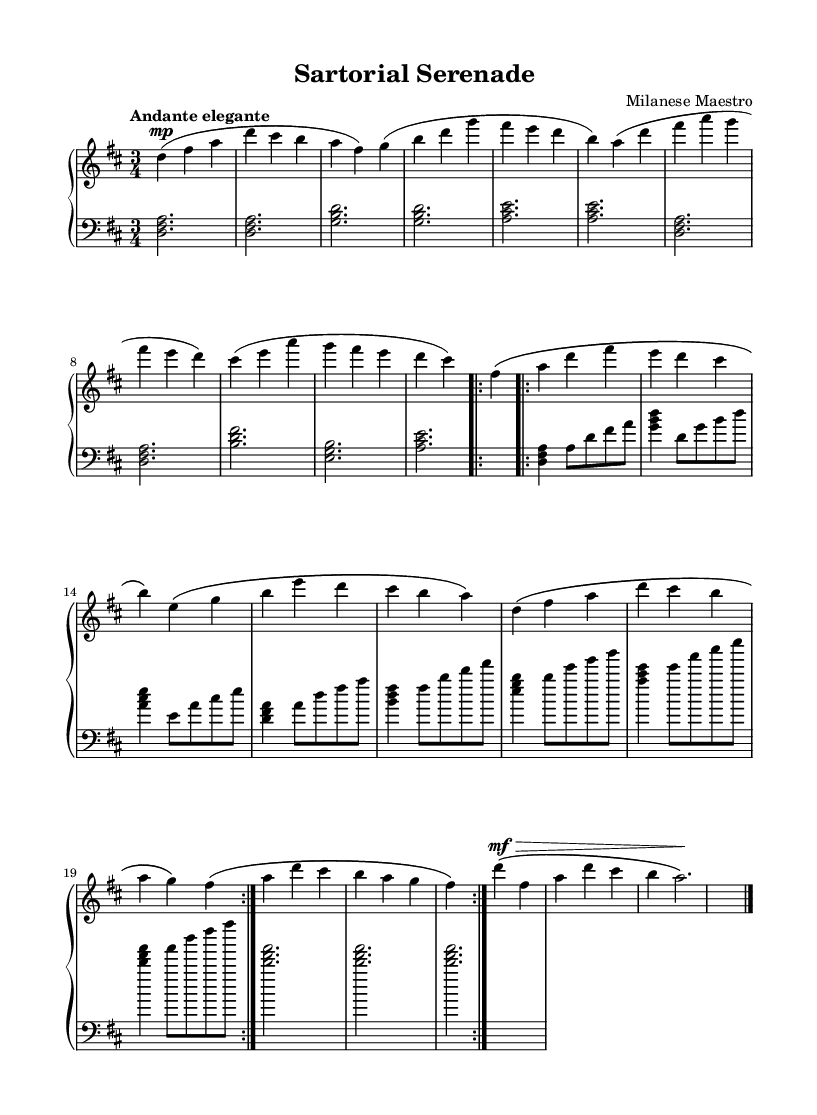What is the key signature of this music? The key signature is D major, which contains two sharps (F# and C#). This can be determined by looking at the key signature shown at the beginning of the staff.
Answer: D major What is the time signature of this music? The time signature is 3/4, indicated at the beginning of the score. This shows that there are three beats in each measure and the quarter note gets one beat.
Answer: 3/4 What is the tempo marking for this piece? The tempo marking is "Andante elegante," which indicates a moderately slow tempo with a sense of elegance. This can be found written above the staff.
Answer: Andante elegante How many measures are in the A section before repetition? There are 8 measures in the A section before the repeat occurs. This can be counted from the beginning of the A section until the repeat sign, which is also indicated in the score.
Answer: 8 What dynamic marking is applied to the Coda's first note? The dynamic marking for the first note of the Coda is "mf" (mezzo-forte), showing it should be played moderately loud. This is indicated right before the note in the score.
Answer: mf What is the final chord in the Coda? The final chord in the Coda is <d fis a>, which consists of the notes D, F#, and A, forming a D major chord. This can be found at the end of the Coda section in the left-hand part.
Answer: <d fis a> 